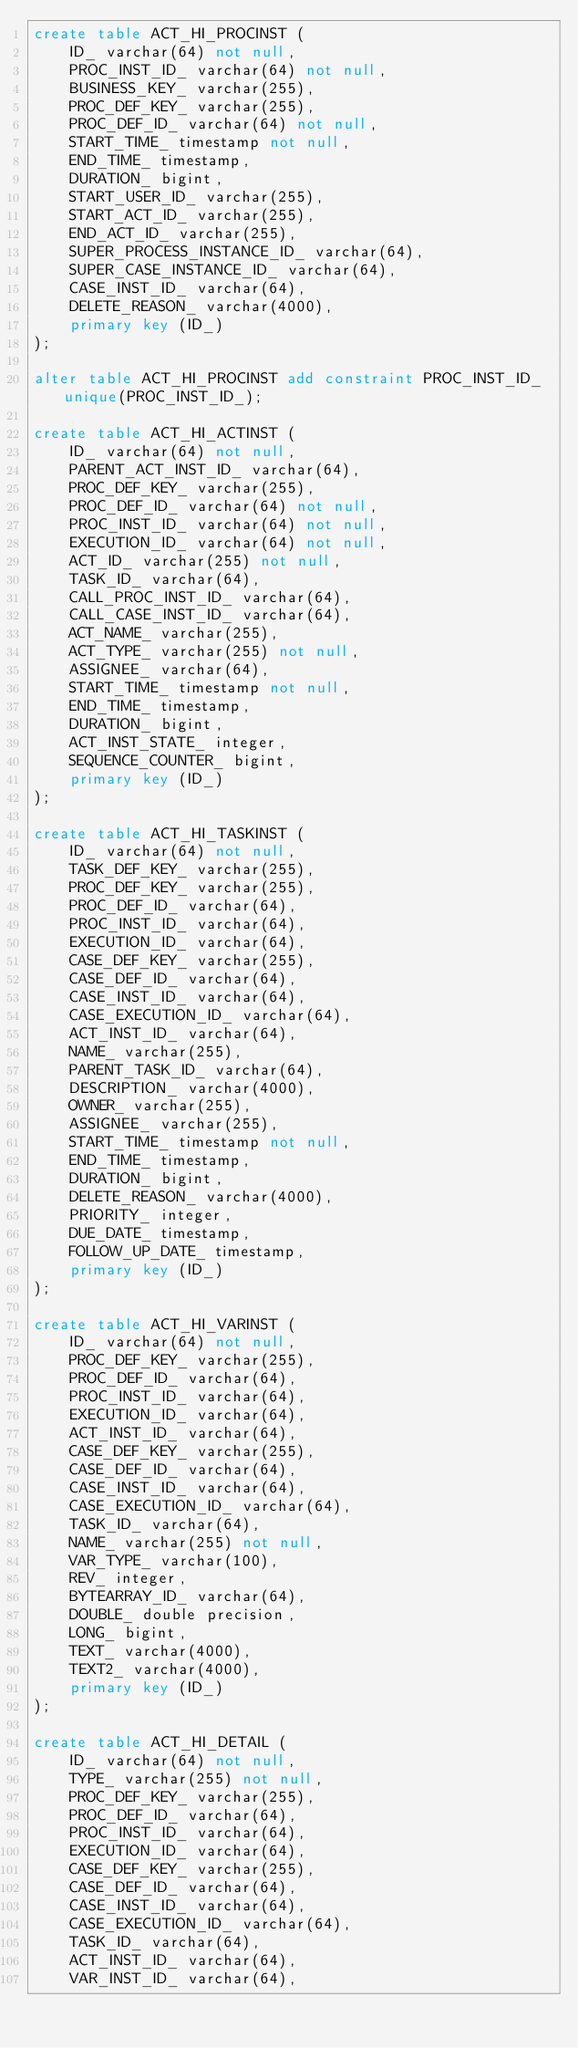<code> <loc_0><loc_0><loc_500><loc_500><_SQL_>create table ACT_HI_PROCINST (
    ID_ varchar(64) not null,
    PROC_INST_ID_ varchar(64) not null,
    BUSINESS_KEY_ varchar(255),
    PROC_DEF_KEY_ varchar(255),
    PROC_DEF_ID_ varchar(64) not null,
    START_TIME_ timestamp not null,
    END_TIME_ timestamp,
    DURATION_ bigint,
    START_USER_ID_ varchar(255),
    START_ACT_ID_ varchar(255),
    END_ACT_ID_ varchar(255),
    SUPER_PROCESS_INSTANCE_ID_ varchar(64),
    SUPER_CASE_INSTANCE_ID_ varchar(64),
    CASE_INST_ID_ varchar(64),
    DELETE_REASON_ varchar(4000),
    primary key (ID_)
);

alter table ACT_HI_PROCINST add constraint PROC_INST_ID_ unique(PROC_INST_ID_);

create table ACT_HI_ACTINST (
    ID_ varchar(64) not null,
    PARENT_ACT_INST_ID_ varchar(64),
    PROC_DEF_KEY_ varchar(255),
    PROC_DEF_ID_ varchar(64) not null,
    PROC_INST_ID_ varchar(64) not null,
    EXECUTION_ID_ varchar(64) not null,
    ACT_ID_ varchar(255) not null,
    TASK_ID_ varchar(64),
    CALL_PROC_INST_ID_ varchar(64),
    CALL_CASE_INST_ID_ varchar(64),
    ACT_NAME_ varchar(255),
    ACT_TYPE_ varchar(255) not null,
    ASSIGNEE_ varchar(64),
    START_TIME_ timestamp not null,
    END_TIME_ timestamp,
    DURATION_ bigint,
    ACT_INST_STATE_ integer,
    SEQUENCE_COUNTER_ bigint,
    primary key (ID_)
);

create table ACT_HI_TASKINST (
    ID_ varchar(64) not null,
    TASK_DEF_KEY_ varchar(255),
    PROC_DEF_KEY_ varchar(255),
    PROC_DEF_ID_ varchar(64),
    PROC_INST_ID_ varchar(64),
    EXECUTION_ID_ varchar(64),
    CASE_DEF_KEY_ varchar(255),
    CASE_DEF_ID_ varchar(64),
    CASE_INST_ID_ varchar(64),
    CASE_EXECUTION_ID_ varchar(64),
    ACT_INST_ID_ varchar(64),
    NAME_ varchar(255),
    PARENT_TASK_ID_ varchar(64),
    DESCRIPTION_ varchar(4000),
    OWNER_ varchar(255),
    ASSIGNEE_ varchar(255),
    START_TIME_ timestamp not null,
    END_TIME_ timestamp,
    DURATION_ bigint,
    DELETE_REASON_ varchar(4000),
    PRIORITY_ integer,
    DUE_DATE_ timestamp,
    FOLLOW_UP_DATE_ timestamp,
    primary key (ID_)
);

create table ACT_HI_VARINST (
    ID_ varchar(64) not null,
    PROC_DEF_KEY_ varchar(255),
    PROC_DEF_ID_ varchar(64),
    PROC_INST_ID_ varchar(64),
    EXECUTION_ID_ varchar(64),
    ACT_INST_ID_ varchar(64),
    CASE_DEF_KEY_ varchar(255),
    CASE_DEF_ID_ varchar(64),
    CASE_INST_ID_ varchar(64),
    CASE_EXECUTION_ID_ varchar(64),
    TASK_ID_ varchar(64),
    NAME_ varchar(255) not null,
    VAR_TYPE_ varchar(100),
    REV_ integer,
    BYTEARRAY_ID_ varchar(64),
    DOUBLE_ double precision,
    LONG_ bigint,
    TEXT_ varchar(4000),
    TEXT2_ varchar(4000),
    primary key (ID_)
);

create table ACT_HI_DETAIL (
    ID_ varchar(64) not null,
    TYPE_ varchar(255) not null,
    PROC_DEF_KEY_ varchar(255),
    PROC_DEF_ID_ varchar(64),
    PROC_INST_ID_ varchar(64),
    EXECUTION_ID_ varchar(64),
    CASE_DEF_KEY_ varchar(255),
    CASE_DEF_ID_ varchar(64),
    CASE_INST_ID_ varchar(64),
    CASE_EXECUTION_ID_ varchar(64),
    TASK_ID_ varchar(64),
    ACT_INST_ID_ varchar(64),
    VAR_INST_ID_ varchar(64),</code> 